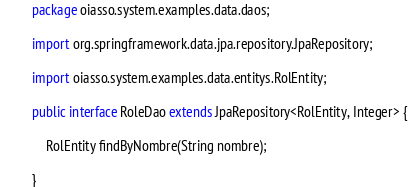Convert code to text. <code><loc_0><loc_0><loc_500><loc_500><_Java_>package oiasso.system.examples.data.daos;

import org.springframework.data.jpa.repository.JpaRepository;

import oiasso.system.examples.data.entitys.RolEntity;

public interface RoleDao extends JpaRepository<RolEntity, Integer> {

	RolEntity findByNombre(String nombre);
	
}
</code> 